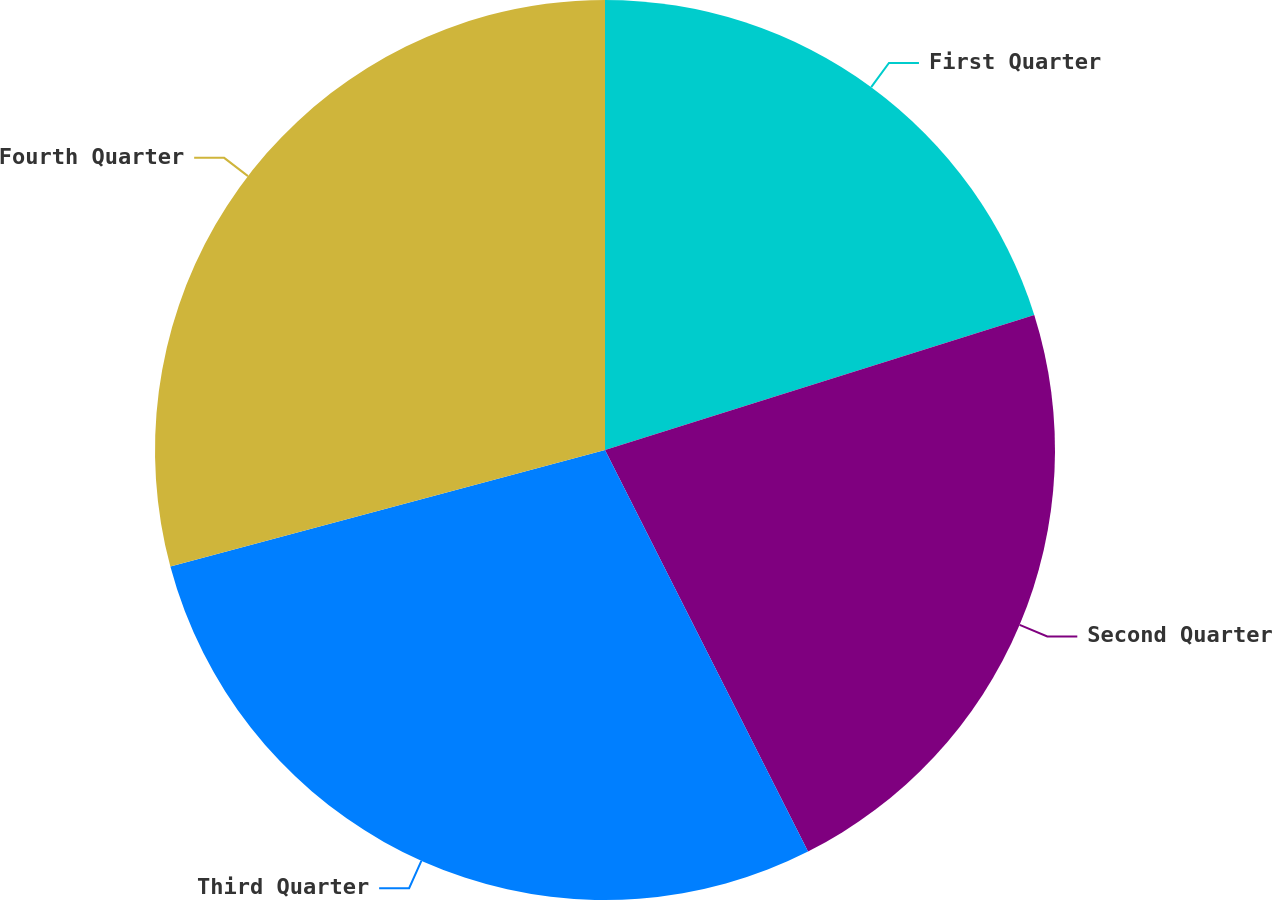<chart> <loc_0><loc_0><loc_500><loc_500><pie_chart><fcel>First Quarter<fcel>Second Quarter<fcel>Third Quarter<fcel>Fourth Quarter<nl><fcel>20.15%<fcel>22.4%<fcel>28.28%<fcel>29.17%<nl></chart> 